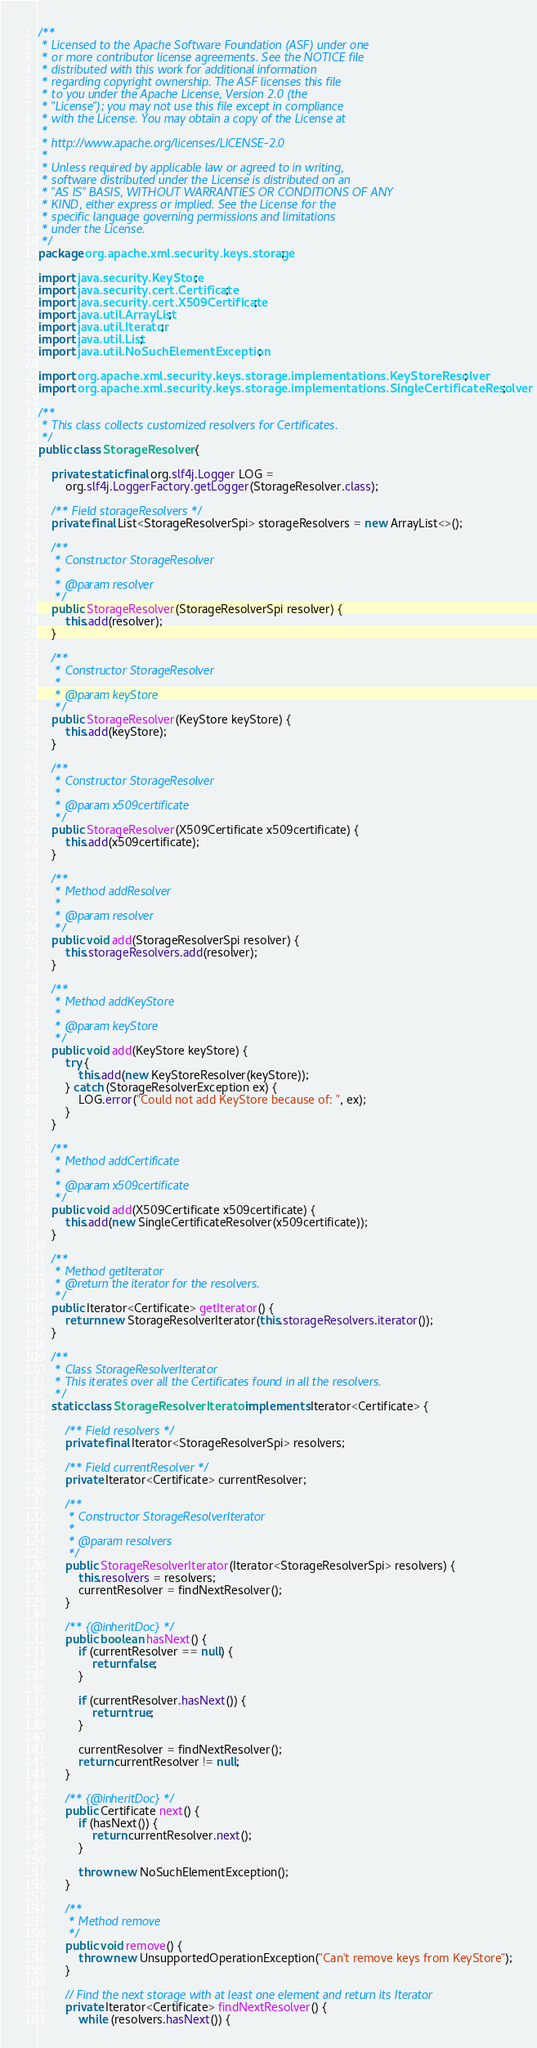Convert code to text. <code><loc_0><loc_0><loc_500><loc_500><_Java_>/**
 * Licensed to the Apache Software Foundation (ASF) under one
 * or more contributor license agreements. See the NOTICE file
 * distributed with this work for additional information
 * regarding copyright ownership. The ASF licenses this file
 * to you under the Apache License, Version 2.0 (the
 * "License"); you may not use this file except in compliance
 * with the License. You may obtain a copy of the License at
 *
 * http://www.apache.org/licenses/LICENSE-2.0
 *
 * Unless required by applicable law or agreed to in writing,
 * software distributed under the License is distributed on an
 * "AS IS" BASIS, WITHOUT WARRANTIES OR CONDITIONS OF ANY
 * KIND, either express or implied. See the License for the
 * specific language governing permissions and limitations
 * under the License.
 */
package org.apache.xml.security.keys.storage;

import java.security.KeyStore;
import java.security.cert.Certificate;
import java.security.cert.X509Certificate;
import java.util.ArrayList;
import java.util.Iterator;
import java.util.List;
import java.util.NoSuchElementException;

import org.apache.xml.security.keys.storage.implementations.KeyStoreResolver;
import org.apache.xml.security.keys.storage.implementations.SingleCertificateResolver;

/**
 * This class collects customized resolvers for Certificates.
 */
public class StorageResolver {

    private static final org.slf4j.Logger LOG =
        org.slf4j.LoggerFactory.getLogger(StorageResolver.class);

    /** Field storageResolvers */
    private final List<StorageResolverSpi> storageResolvers = new ArrayList<>();

    /**
     * Constructor StorageResolver
     *
     * @param resolver
     */
    public StorageResolver(StorageResolverSpi resolver) {
        this.add(resolver);
    }

    /**
     * Constructor StorageResolver
     *
     * @param keyStore
     */
    public StorageResolver(KeyStore keyStore) {
        this.add(keyStore);
    }

    /**
     * Constructor StorageResolver
     *
     * @param x509certificate
     */
    public StorageResolver(X509Certificate x509certificate) {
        this.add(x509certificate);
    }

    /**
     * Method addResolver
     *
     * @param resolver
     */
    public void add(StorageResolverSpi resolver) {
        this.storageResolvers.add(resolver);
    }

    /**
     * Method addKeyStore
     *
     * @param keyStore
     */
    public void add(KeyStore keyStore) {
        try {
            this.add(new KeyStoreResolver(keyStore));
        } catch (StorageResolverException ex) {
            LOG.error("Could not add KeyStore because of: ", ex);
        }
    }

    /**
     * Method addCertificate
     *
     * @param x509certificate
     */
    public void add(X509Certificate x509certificate) {
        this.add(new SingleCertificateResolver(x509certificate));
    }

    /**
     * Method getIterator
     * @return the iterator for the resolvers.
     */
    public Iterator<Certificate> getIterator() {
        return new StorageResolverIterator(this.storageResolvers.iterator());
    }

    /**
     * Class StorageResolverIterator
     * This iterates over all the Certificates found in all the resolvers.
     */
    static class StorageResolverIterator implements Iterator<Certificate> {

        /** Field resolvers */
        private final Iterator<StorageResolverSpi> resolvers;

        /** Field currentResolver */
        private Iterator<Certificate> currentResolver;

        /**
         * Constructor StorageResolverIterator
         *
         * @param resolvers
         */
        public StorageResolverIterator(Iterator<StorageResolverSpi> resolvers) {
            this.resolvers = resolvers;
            currentResolver = findNextResolver();
        }

        /** {@inheritDoc} */
        public boolean hasNext() {
            if (currentResolver == null) {
                return false;
            }

            if (currentResolver.hasNext()) {
                return true;
            }

            currentResolver = findNextResolver();
            return currentResolver != null;
        }

        /** {@inheritDoc} */
        public Certificate next() {
            if (hasNext()) {
                return currentResolver.next();
            }

            throw new NoSuchElementException();
        }

        /**
         * Method remove
         */
        public void remove() {
            throw new UnsupportedOperationException("Can't remove keys from KeyStore");
        }

        // Find the next storage with at least one element and return its Iterator
        private Iterator<Certificate> findNextResolver() {
            while (resolvers.hasNext()) {</code> 